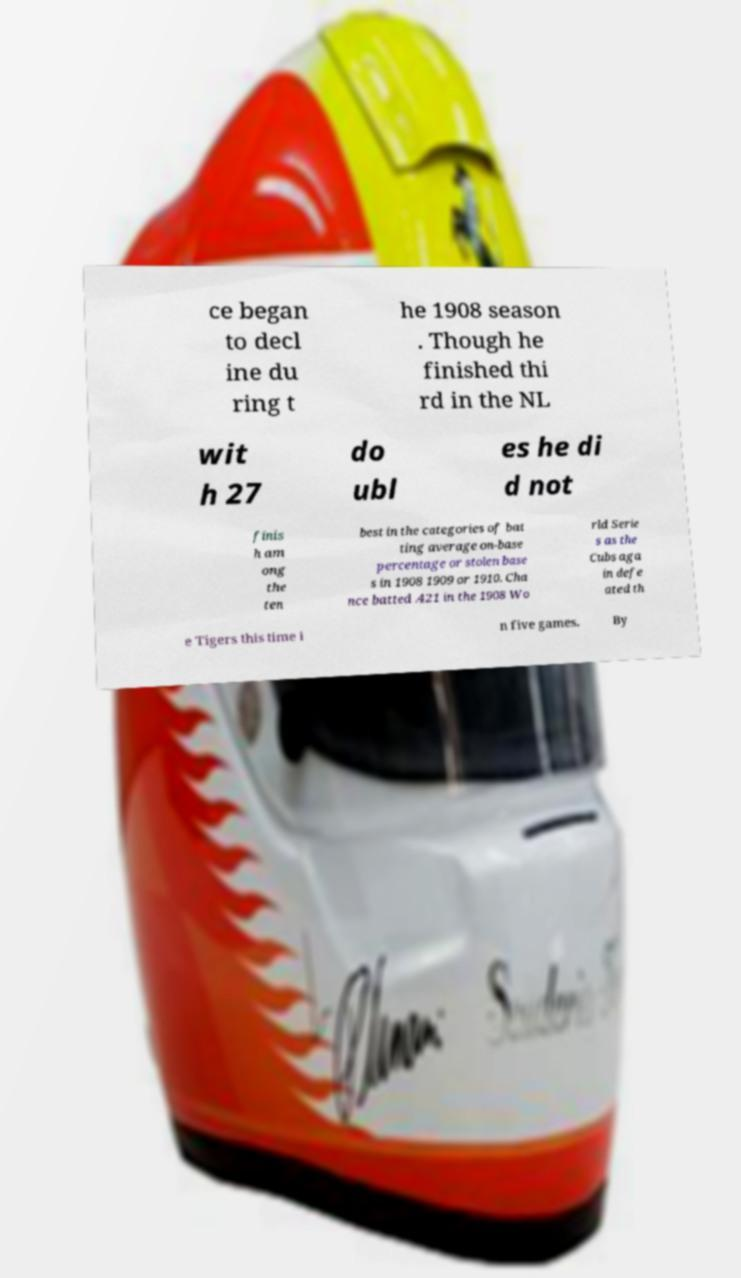What messages or text are displayed in this image? I need them in a readable, typed format. ce began to decl ine du ring t he 1908 season . Though he finished thi rd in the NL wit h 27 do ubl es he di d not finis h am ong the ten best in the categories of bat ting average on-base percentage or stolen base s in 1908 1909 or 1910. Cha nce batted .421 in the 1908 Wo rld Serie s as the Cubs aga in defe ated th e Tigers this time i n five games. By 